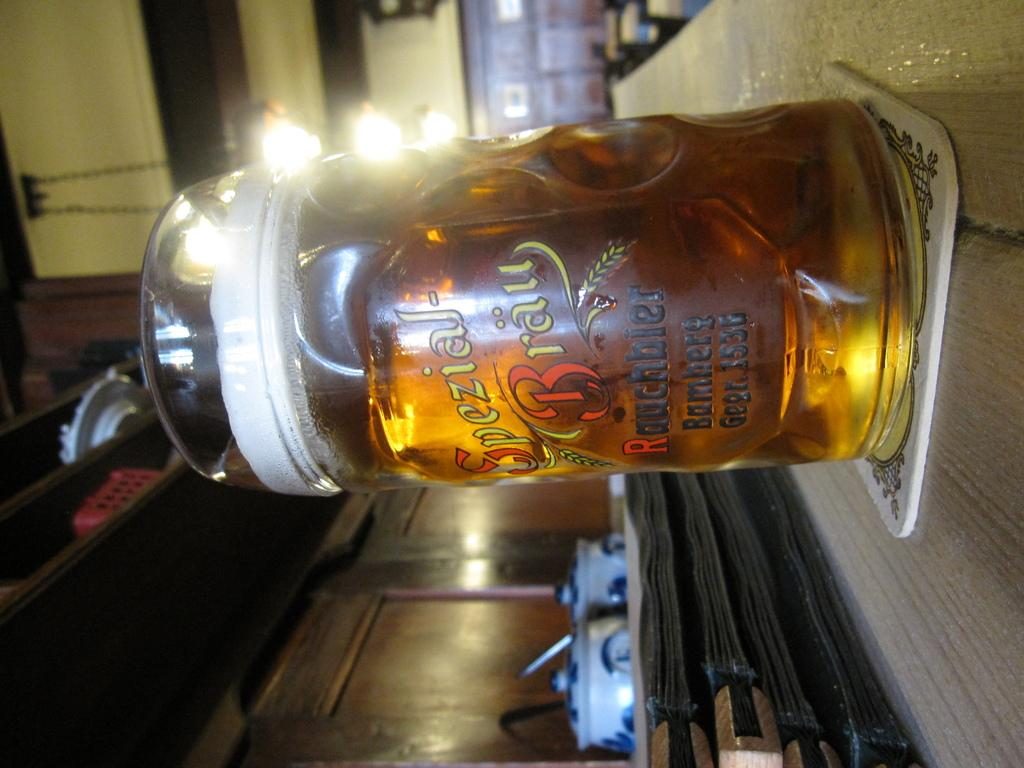Provide a one-sentence caption for the provided image. A beer in a glass with the words special brew written in german. 